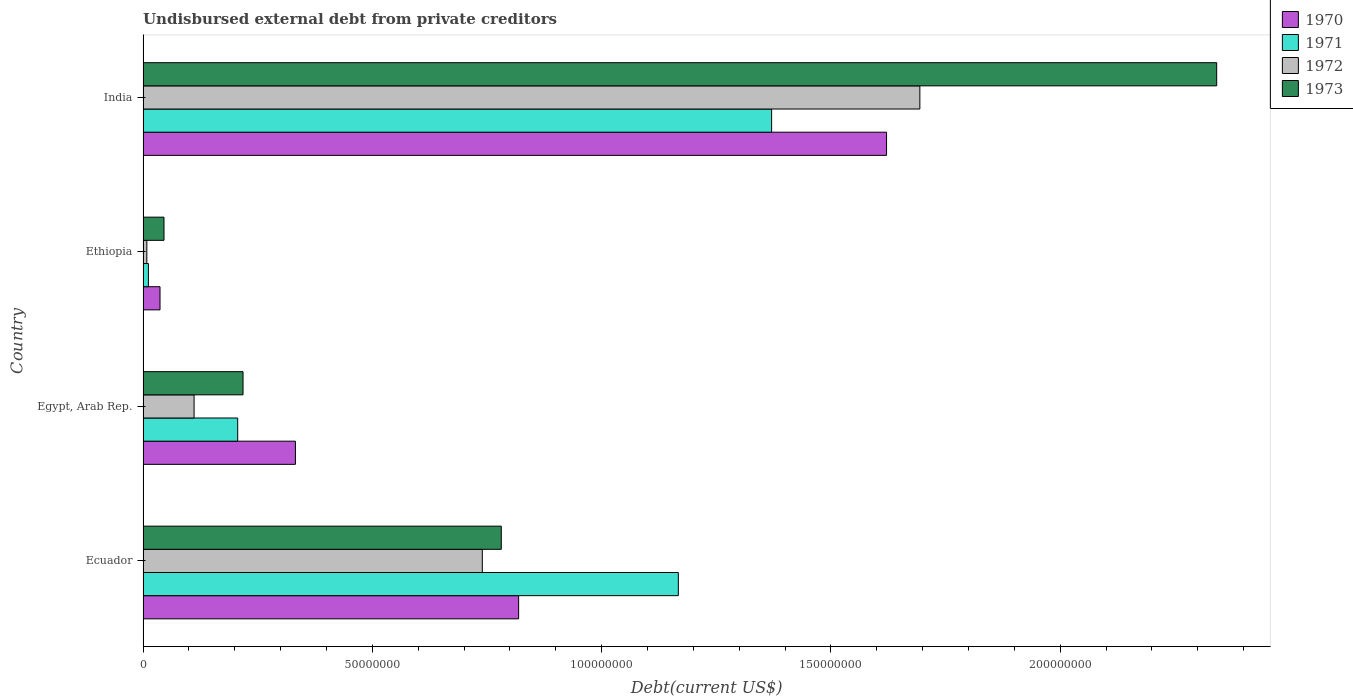How many groups of bars are there?
Ensure brevity in your answer.  4. How many bars are there on the 2nd tick from the bottom?
Your response must be concise. 4. What is the label of the 3rd group of bars from the top?
Offer a very short reply. Egypt, Arab Rep. In how many cases, is the number of bars for a given country not equal to the number of legend labels?
Provide a succinct answer. 0. What is the total debt in 1972 in Ecuador?
Ensure brevity in your answer.  7.40e+07. Across all countries, what is the maximum total debt in 1971?
Your response must be concise. 1.37e+08. Across all countries, what is the minimum total debt in 1970?
Give a very brief answer. 3.70e+06. In which country was the total debt in 1972 minimum?
Your answer should be compact. Ethiopia. What is the total total debt in 1973 in the graph?
Provide a short and direct response. 3.39e+08. What is the difference between the total debt in 1972 in Ethiopia and that in India?
Your answer should be compact. -1.69e+08. What is the difference between the total debt in 1973 in Ecuador and the total debt in 1970 in Ethiopia?
Provide a succinct answer. 7.44e+07. What is the average total debt in 1972 per country?
Offer a very short reply. 6.38e+07. What is the difference between the total debt in 1972 and total debt in 1973 in Ethiopia?
Provide a succinct answer. -3.75e+06. In how many countries, is the total debt in 1972 greater than 120000000 US$?
Make the answer very short. 1. What is the ratio of the total debt in 1970 in Egypt, Arab Rep. to that in Ethiopia?
Your answer should be compact. 8.99. Is the total debt in 1970 in Egypt, Arab Rep. less than that in Ethiopia?
Your answer should be very brief. No. What is the difference between the highest and the second highest total debt in 1973?
Your response must be concise. 1.56e+08. What is the difference between the highest and the lowest total debt in 1972?
Keep it short and to the point. 1.69e+08. What does the 3rd bar from the top in India represents?
Your response must be concise. 1971. What does the 1st bar from the bottom in Egypt, Arab Rep. represents?
Provide a short and direct response. 1970. Is it the case that in every country, the sum of the total debt in 1973 and total debt in 1970 is greater than the total debt in 1972?
Keep it short and to the point. Yes. Are all the bars in the graph horizontal?
Ensure brevity in your answer.  Yes. How many countries are there in the graph?
Provide a succinct answer. 4. Are the values on the major ticks of X-axis written in scientific E-notation?
Offer a very short reply. No. Does the graph contain any zero values?
Give a very brief answer. No. Where does the legend appear in the graph?
Ensure brevity in your answer.  Top right. How are the legend labels stacked?
Make the answer very short. Vertical. What is the title of the graph?
Give a very brief answer. Undisbursed external debt from private creditors. What is the label or title of the X-axis?
Offer a terse response. Debt(current US$). What is the label or title of the Y-axis?
Make the answer very short. Country. What is the Debt(current US$) in 1970 in Ecuador?
Ensure brevity in your answer.  8.19e+07. What is the Debt(current US$) of 1971 in Ecuador?
Your answer should be compact. 1.17e+08. What is the Debt(current US$) of 1972 in Ecuador?
Ensure brevity in your answer.  7.40e+07. What is the Debt(current US$) in 1973 in Ecuador?
Ensure brevity in your answer.  7.81e+07. What is the Debt(current US$) of 1970 in Egypt, Arab Rep.?
Give a very brief answer. 3.32e+07. What is the Debt(current US$) in 1971 in Egypt, Arab Rep.?
Your answer should be compact. 2.06e+07. What is the Debt(current US$) of 1972 in Egypt, Arab Rep.?
Your answer should be very brief. 1.11e+07. What is the Debt(current US$) of 1973 in Egypt, Arab Rep.?
Provide a succinct answer. 2.18e+07. What is the Debt(current US$) of 1970 in Ethiopia?
Provide a succinct answer. 3.70e+06. What is the Debt(current US$) in 1971 in Ethiopia?
Offer a very short reply. 1.16e+06. What is the Debt(current US$) of 1972 in Ethiopia?
Your response must be concise. 8.20e+05. What is the Debt(current US$) in 1973 in Ethiopia?
Give a very brief answer. 4.57e+06. What is the Debt(current US$) of 1970 in India?
Provide a succinct answer. 1.62e+08. What is the Debt(current US$) of 1971 in India?
Offer a terse response. 1.37e+08. What is the Debt(current US$) of 1972 in India?
Provide a short and direct response. 1.69e+08. What is the Debt(current US$) of 1973 in India?
Make the answer very short. 2.34e+08. Across all countries, what is the maximum Debt(current US$) in 1970?
Your answer should be very brief. 1.62e+08. Across all countries, what is the maximum Debt(current US$) in 1971?
Offer a terse response. 1.37e+08. Across all countries, what is the maximum Debt(current US$) in 1972?
Offer a very short reply. 1.69e+08. Across all countries, what is the maximum Debt(current US$) in 1973?
Offer a terse response. 2.34e+08. Across all countries, what is the minimum Debt(current US$) in 1970?
Provide a short and direct response. 3.70e+06. Across all countries, what is the minimum Debt(current US$) in 1971?
Provide a succinct answer. 1.16e+06. Across all countries, what is the minimum Debt(current US$) in 1972?
Your answer should be very brief. 8.20e+05. Across all countries, what is the minimum Debt(current US$) of 1973?
Your answer should be very brief. 4.57e+06. What is the total Debt(current US$) in 1970 in the graph?
Make the answer very short. 2.81e+08. What is the total Debt(current US$) of 1971 in the graph?
Your answer should be compact. 2.76e+08. What is the total Debt(current US$) in 1972 in the graph?
Your answer should be very brief. 2.55e+08. What is the total Debt(current US$) in 1973 in the graph?
Your response must be concise. 3.39e+08. What is the difference between the Debt(current US$) in 1970 in Ecuador and that in Egypt, Arab Rep.?
Provide a short and direct response. 4.87e+07. What is the difference between the Debt(current US$) of 1971 in Ecuador and that in Egypt, Arab Rep.?
Provide a succinct answer. 9.61e+07. What is the difference between the Debt(current US$) in 1972 in Ecuador and that in Egypt, Arab Rep.?
Ensure brevity in your answer.  6.28e+07. What is the difference between the Debt(current US$) of 1973 in Ecuador and that in Egypt, Arab Rep.?
Provide a succinct answer. 5.63e+07. What is the difference between the Debt(current US$) in 1970 in Ecuador and that in Ethiopia?
Provide a short and direct response. 7.82e+07. What is the difference between the Debt(current US$) in 1971 in Ecuador and that in Ethiopia?
Your answer should be very brief. 1.16e+08. What is the difference between the Debt(current US$) of 1972 in Ecuador and that in Ethiopia?
Provide a short and direct response. 7.32e+07. What is the difference between the Debt(current US$) in 1973 in Ecuador and that in Ethiopia?
Give a very brief answer. 7.35e+07. What is the difference between the Debt(current US$) of 1970 in Ecuador and that in India?
Provide a succinct answer. -8.02e+07. What is the difference between the Debt(current US$) of 1971 in Ecuador and that in India?
Give a very brief answer. -2.03e+07. What is the difference between the Debt(current US$) of 1972 in Ecuador and that in India?
Ensure brevity in your answer.  -9.54e+07. What is the difference between the Debt(current US$) of 1973 in Ecuador and that in India?
Provide a short and direct response. -1.56e+08. What is the difference between the Debt(current US$) in 1970 in Egypt, Arab Rep. and that in Ethiopia?
Your answer should be compact. 2.95e+07. What is the difference between the Debt(current US$) of 1971 in Egypt, Arab Rep. and that in Ethiopia?
Give a very brief answer. 1.95e+07. What is the difference between the Debt(current US$) of 1972 in Egypt, Arab Rep. and that in Ethiopia?
Make the answer very short. 1.03e+07. What is the difference between the Debt(current US$) of 1973 in Egypt, Arab Rep. and that in Ethiopia?
Offer a terse response. 1.72e+07. What is the difference between the Debt(current US$) of 1970 in Egypt, Arab Rep. and that in India?
Offer a terse response. -1.29e+08. What is the difference between the Debt(current US$) in 1971 in Egypt, Arab Rep. and that in India?
Give a very brief answer. -1.16e+08. What is the difference between the Debt(current US$) of 1972 in Egypt, Arab Rep. and that in India?
Your answer should be very brief. -1.58e+08. What is the difference between the Debt(current US$) in 1973 in Egypt, Arab Rep. and that in India?
Keep it short and to the point. -2.12e+08. What is the difference between the Debt(current US$) of 1970 in Ethiopia and that in India?
Provide a succinct answer. -1.58e+08. What is the difference between the Debt(current US$) of 1971 in Ethiopia and that in India?
Your response must be concise. -1.36e+08. What is the difference between the Debt(current US$) of 1972 in Ethiopia and that in India?
Your answer should be very brief. -1.69e+08. What is the difference between the Debt(current US$) of 1973 in Ethiopia and that in India?
Provide a succinct answer. -2.30e+08. What is the difference between the Debt(current US$) of 1970 in Ecuador and the Debt(current US$) of 1971 in Egypt, Arab Rep.?
Offer a very short reply. 6.13e+07. What is the difference between the Debt(current US$) in 1970 in Ecuador and the Debt(current US$) in 1972 in Egypt, Arab Rep.?
Your answer should be very brief. 7.08e+07. What is the difference between the Debt(current US$) in 1970 in Ecuador and the Debt(current US$) in 1973 in Egypt, Arab Rep.?
Offer a terse response. 6.01e+07. What is the difference between the Debt(current US$) in 1971 in Ecuador and the Debt(current US$) in 1972 in Egypt, Arab Rep.?
Make the answer very short. 1.06e+08. What is the difference between the Debt(current US$) of 1971 in Ecuador and the Debt(current US$) of 1973 in Egypt, Arab Rep.?
Provide a succinct answer. 9.49e+07. What is the difference between the Debt(current US$) in 1972 in Ecuador and the Debt(current US$) in 1973 in Egypt, Arab Rep.?
Offer a terse response. 5.22e+07. What is the difference between the Debt(current US$) of 1970 in Ecuador and the Debt(current US$) of 1971 in Ethiopia?
Your answer should be compact. 8.07e+07. What is the difference between the Debt(current US$) of 1970 in Ecuador and the Debt(current US$) of 1972 in Ethiopia?
Your answer should be very brief. 8.11e+07. What is the difference between the Debt(current US$) of 1970 in Ecuador and the Debt(current US$) of 1973 in Ethiopia?
Give a very brief answer. 7.73e+07. What is the difference between the Debt(current US$) in 1971 in Ecuador and the Debt(current US$) in 1972 in Ethiopia?
Provide a short and direct response. 1.16e+08. What is the difference between the Debt(current US$) of 1971 in Ecuador and the Debt(current US$) of 1973 in Ethiopia?
Offer a very short reply. 1.12e+08. What is the difference between the Debt(current US$) of 1972 in Ecuador and the Debt(current US$) of 1973 in Ethiopia?
Offer a terse response. 6.94e+07. What is the difference between the Debt(current US$) in 1970 in Ecuador and the Debt(current US$) in 1971 in India?
Provide a succinct answer. -5.52e+07. What is the difference between the Debt(current US$) of 1970 in Ecuador and the Debt(current US$) of 1972 in India?
Offer a terse response. -8.75e+07. What is the difference between the Debt(current US$) in 1970 in Ecuador and the Debt(current US$) in 1973 in India?
Your answer should be very brief. -1.52e+08. What is the difference between the Debt(current US$) of 1971 in Ecuador and the Debt(current US$) of 1972 in India?
Give a very brief answer. -5.27e+07. What is the difference between the Debt(current US$) of 1971 in Ecuador and the Debt(current US$) of 1973 in India?
Your answer should be compact. -1.17e+08. What is the difference between the Debt(current US$) in 1972 in Ecuador and the Debt(current US$) in 1973 in India?
Provide a short and direct response. -1.60e+08. What is the difference between the Debt(current US$) in 1970 in Egypt, Arab Rep. and the Debt(current US$) in 1971 in Ethiopia?
Offer a terse response. 3.21e+07. What is the difference between the Debt(current US$) in 1970 in Egypt, Arab Rep. and the Debt(current US$) in 1972 in Ethiopia?
Offer a terse response. 3.24e+07. What is the difference between the Debt(current US$) in 1970 in Egypt, Arab Rep. and the Debt(current US$) in 1973 in Ethiopia?
Keep it short and to the point. 2.87e+07. What is the difference between the Debt(current US$) in 1971 in Egypt, Arab Rep. and the Debt(current US$) in 1972 in Ethiopia?
Give a very brief answer. 1.98e+07. What is the difference between the Debt(current US$) of 1971 in Egypt, Arab Rep. and the Debt(current US$) of 1973 in Ethiopia?
Your answer should be very brief. 1.61e+07. What is the difference between the Debt(current US$) of 1972 in Egypt, Arab Rep. and the Debt(current US$) of 1973 in Ethiopia?
Offer a terse response. 6.56e+06. What is the difference between the Debt(current US$) in 1970 in Egypt, Arab Rep. and the Debt(current US$) in 1971 in India?
Your answer should be very brief. -1.04e+08. What is the difference between the Debt(current US$) in 1970 in Egypt, Arab Rep. and the Debt(current US$) in 1972 in India?
Provide a succinct answer. -1.36e+08. What is the difference between the Debt(current US$) of 1970 in Egypt, Arab Rep. and the Debt(current US$) of 1973 in India?
Provide a short and direct response. -2.01e+08. What is the difference between the Debt(current US$) of 1971 in Egypt, Arab Rep. and the Debt(current US$) of 1972 in India?
Provide a short and direct response. -1.49e+08. What is the difference between the Debt(current US$) of 1971 in Egypt, Arab Rep. and the Debt(current US$) of 1973 in India?
Give a very brief answer. -2.13e+08. What is the difference between the Debt(current US$) of 1972 in Egypt, Arab Rep. and the Debt(current US$) of 1973 in India?
Provide a short and direct response. -2.23e+08. What is the difference between the Debt(current US$) in 1970 in Ethiopia and the Debt(current US$) in 1971 in India?
Your response must be concise. -1.33e+08. What is the difference between the Debt(current US$) of 1970 in Ethiopia and the Debt(current US$) of 1972 in India?
Provide a short and direct response. -1.66e+08. What is the difference between the Debt(current US$) in 1970 in Ethiopia and the Debt(current US$) in 1973 in India?
Your answer should be very brief. -2.30e+08. What is the difference between the Debt(current US$) in 1971 in Ethiopia and the Debt(current US$) in 1972 in India?
Provide a short and direct response. -1.68e+08. What is the difference between the Debt(current US$) in 1971 in Ethiopia and the Debt(current US$) in 1973 in India?
Offer a terse response. -2.33e+08. What is the difference between the Debt(current US$) in 1972 in Ethiopia and the Debt(current US$) in 1973 in India?
Keep it short and to the point. -2.33e+08. What is the average Debt(current US$) in 1970 per country?
Ensure brevity in your answer.  7.02e+07. What is the average Debt(current US$) of 1971 per country?
Ensure brevity in your answer.  6.89e+07. What is the average Debt(current US$) of 1972 per country?
Give a very brief answer. 6.38e+07. What is the average Debt(current US$) in 1973 per country?
Offer a terse response. 8.46e+07. What is the difference between the Debt(current US$) in 1970 and Debt(current US$) in 1971 in Ecuador?
Keep it short and to the point. -3.48e+07. What is the difference between the Debt(current US$) of 1970 and Debt(current US$) of 1972 in Ecuador?
Provide a succinct answer. 7.92e+06. What is the difference between the Debt(current US$) of 1970 and Debt(current US$) of 1973 in Ecuador?
Make the answer very short. 3.78e+06. What is the difference between the Debt(current US$) of 1971 and Debt(current US$) of 1972 in Ecuador?
Your response must be concise. 4.27e+07. What is the difference between the Debt(current US$) in 1971 and Debt(current US$) in 1973 in Ecuador?
Offer a terse response. 3.86e+07. What is the difference between the Debt(current US$) in 1972 and Debt(current US$) in 1973 in Ecuador?
Ensure brevity in your answer.  -4.14e+06. What is the difference between the Debt(current US$) in 1970 and Debt(current US$) in 1971 in Egypt, Arab Rep.?
Your answer should be compact. 1.26e+07. What is the difference between the Debt(current US$) of 1970 and Debt(current US$) of 1972 in Egypt, Arab Rep.?
Provide a succinct answer. 2.21e+07. What is the difference between the Debt(current US$) of 1970 and Debt(current US$) of 1973 in Egypt, Arab Rep.?
Give a very brief answer. 1.14e+07. What is the difference between the Debt(current US$) of 1971 and Debt(current US$) of 1972 in Egypt, Arab Rep.?
Your answer should be very brief. 9.50e+06. What is the difference between the Debt(current US$) in 1971 and Debt(current US$) in 1973 in Egypt, Arab Rep.?
Provide a succinct answer. -1.17e+06. What is the difference between the Debt(current US$) of 1972 and Debt(current US$) of 1973 in Egypt, Arab Rep.?
Offer a terse response. -1.07e+07. What is the difference between the Debt(current US$) in 1970 and Debt(current US$) in 1971 in Ethiopia?
Your answer should be compact. 2.53e+06. What is the difference between the Debt(current US$) of 1970 and Debt(current US$) of 1972 in Ethiopia?
Offer a very short reply. 2.88e+06. What is the difference between the Debt(current US$) in 1970 and Debt(current US$) in 1973 in Ethiopia?
Your answer should be compact. -8.70e+05. What is the difference between the Debt(current US$) in 1971 and Debt(current US$) in 1972 in Ethiopia?
Keep it short and to the point. 3.45e+05. What is the difference between the Debt(current US$) in 1971 and Debt(current US$) in 1973 in Ethiopia?
Ensure brevity in your answer.  -3.40e+06. What is the difference between the Debt(current US$) of 1972 and Debt(current US$) of 1973 in Ethiopia?
Make the answer very short. -3.75e+06. What is the difference between the Debt(current US$) in 1970 and Debt(current US$) in 1971 in India?
Make the answer very short. 2.51e+07. What is the difference between the Debt(current US$) of 1970 and Debt(current US$) of 1972 in India?
Ensure brevity in your answer.  -7.26e+06. What is the difference between the Debt(current US$) in 1970 and Debt(current US$) in 1973 in India?
Provide a succinct answer. -7.20e+07. What is the difference between the Debt(current US$) in 1971 and Debt(current US$) in 1972 in India?
Your response must be concise. -3.23e+07. What is the difference between the Debt(current US$) of 1971 and Debt(current US$) of 1973 in India?
Provide a succinct answer. -9.70e+07. What is the difference between the Debt(current US$) in 1972 and Debt(current US$) in 1973 in India?
Give a very brief answer. -6.47e+07. What is the ratio of the Debt(current US$) in 1970 in Ecuador to that in Egypt, Arab Rep.?
Provide a succinct answer. 2.47. What is the ratio of the Debt(current US$) in 1971 in Ecuador to that in Egypt, Arab Rep.?
Make the answer very short. 5.66. What is the ratio of the Debt(current US$) of 1972 in Ecuador to that in Egypt, Arab Rep.?
Your answer should be compact. 6.65. What is the ratio of the Debt(current US$) of 1973 in Ecuador to that in Egypt, Arab Rep.?
Your answer should be compact. 3.58. What is the ratio of the Debt(current US$) of 1970 in Ecuador to that in Ethiopia?
Provide a short and direct response. 22.15. What is the ratio of the Debt(current US$) in 1971 in Ecuador to that in Ethiopia?
Make the answer very short. 100.19. What is the ratio of the Debt(current US$) in 1972 in Ecuador to that in Ethiopia?
Make the answer very short. 90.21. What is the ratio of the Debt(current US$) of 1973 in Ecuador to that in Ethiopia?
Your answer should be very brief. 17.1. What is the ratio of the Debt(current US$) of 1970 in Ecuador to that in India?
Your answer should be very brief. 0.51. What is the ratio of the Debt(current US$) of 1971 in Ecuador to that in India?
Offer a very short reply. 0.85. What is the ratio of the Debt(current US$) in 1972 in Ecuador to that in India?
Offer a terse response. 0.44. What is the ratio of the Debt(current US$) of 1973 in Ecuador to that in India?
Offer a terse response. 0.33. What is the ratio of the Debt(current US$) of 1970 in Egypt, Arab Rep. to that in Ethiopia?
Your response must be concise. 8.99. What is the ratio of the Debt(current US$) in 1971 in Egypt, Arab Rep. to that in Ethiopia?
Make the answer very short. 17.71. What is the ratio of the Debt(current US$) of 1972 in Egypt, Arab Rep. to that in Ethiopia?
Offer a very short reply. 13.57. What is the ratio of the Debt(current US$) of 1973 in Egypt, Arab Rep. to that in Ethiopia?
Your response must be concise. 4.77. What is the ratio of the Debt(current US$) in 1970 in Egypt, Arab Rep. to that in India?
Offer a very short reply. 0.2. What is the ratio of the Debt(current US$) of 1971 in Egypt, Arab Rep. to that in India?
Make the answer very short. 0.15. What is the ratio of the Debt(current US$) of 1972 in Egypt, Arab Rep. to that in India?
Your answer should be compact. 0.07. What is the ratio of the Debt(current US$) in 1973 in Egypt, Arab Rep. to that in India?
Give a very brief answer. 0.09. What is the ratio of the Debt(current US$) in 1970 in Ethiopia to that in India?
Make the answer very short. 0.02. What is the ratio of the Debt(current US$) of 1971 in Ethiopia to that in India?
Keep it short and to the point. 0.01. What is the ratio of the Debt(current US$) in 1972 in Ethiopia to that in India?
Your answer should be very brief. 0. What is the ratio of the Debt(current US$) in 1973 in Ethiopia to that in India?
Keep it short and to the point. 0.02. What is the difference between the highest and the second highest Debt(current US$) of 1970?
Your response must be concise. 8.02e+07. What is the difference between the highest and the second highest Debt(current US$) of 1971?
Provide a short and direct response. 2.03e+07. What is the difference between the highest and the second highest Debt(current US$) in 1972?
Give a very brief answer. 9.54e+07. What is the difference between the highest and the second highest Debt(current US$) of 1973?
Keep it short and to the point. 1.56e+08. What is the difference between the highest and the lowest Debt(current US$) of 1970?
Provide a short and direct response. 1.58e+08. What is the difference between the highest and the lowest Debt(current US$) of 1971?
Ensure brevity in your answer.  1.36e+08. What is the difference between the highest and the lowest Debt(current US$) in 1972?
Offer a very short reply. 1.69e+08. What is the difference between the highest and the lowest Debt(current US$) of 1973?
Make the answer very short. 2.30e+08. 